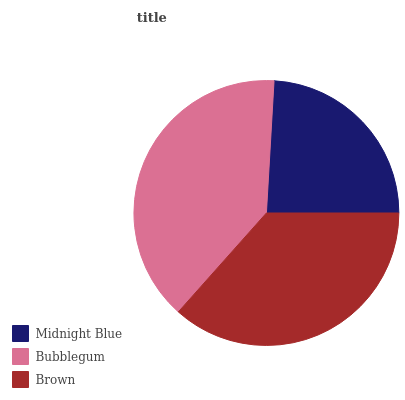Is Midnight Blue the minimum?
Answer yes or no. Yes. Is Bubblegum the maximum?
Answer yes or no. Yes. Is Brown the minimum?
Answer yes or no. No. Is Brown the maximum?
Answer yes or no. No. Is Bubblegum greater than Brown?
Answer yes or no. Yes. Is Brown less than Bubblegum?
Answer yes or no. Yes. Is Brown greater than Bubblegum?
Answer yes or no. No. Is Bubblegum less than Brown?
Answer yes or no. No. Is Brown the high median?
Answer yes or no. Yes. Is Brown the low median?
Answer yes or no. Yes. Is Bubblegum the high median?
Answer yes or no. No. Is Midnight Blue the low median?
Answer yes or no. No. 